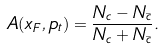Convert formula to latex. <formula><loc_0><loc_0><loc_500><loc_500>A ( x _ { F } , p _ { t } ) = \frac { N _ { c } - N _ { \bar { c } } } { N _ { c } + N _ { \bar { c } } } .</formula> 